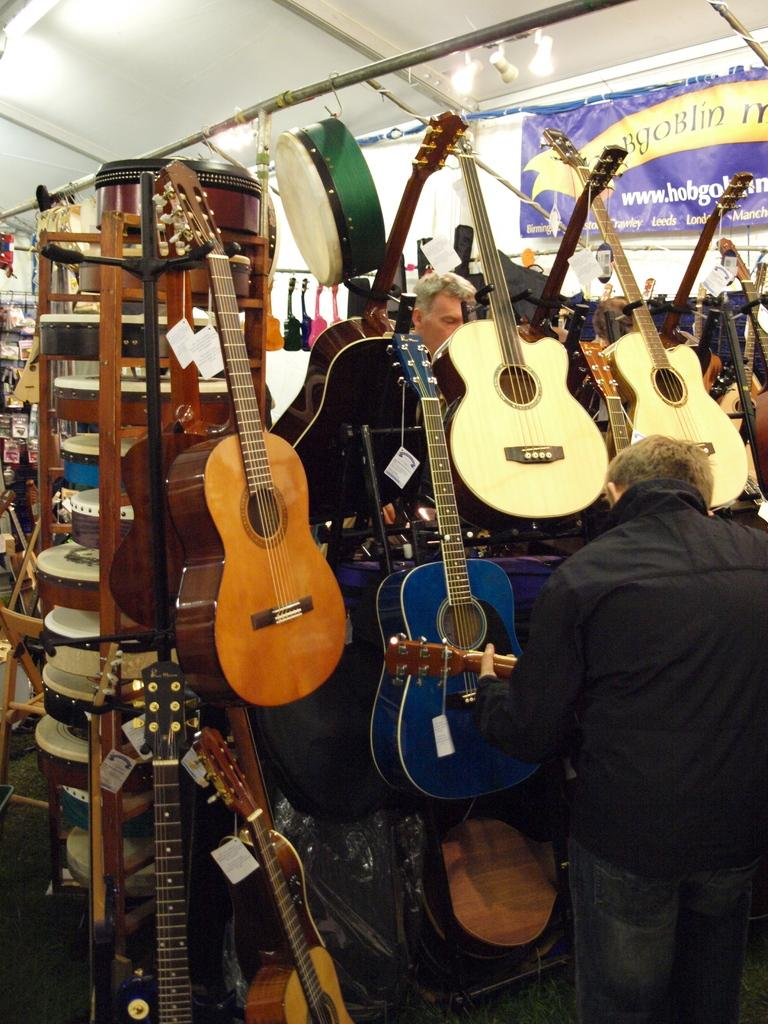What musical instruments are present in the image? There are guitars in the image. Who is present in the image besides the guitars? There is a man standing in the image. What is the man standing on? The man is standing on the floor. What type of account does the man have at the hospital in the image? There is no hospital or account mentioned in the image; it only features guitars and a man standing on the floor. 